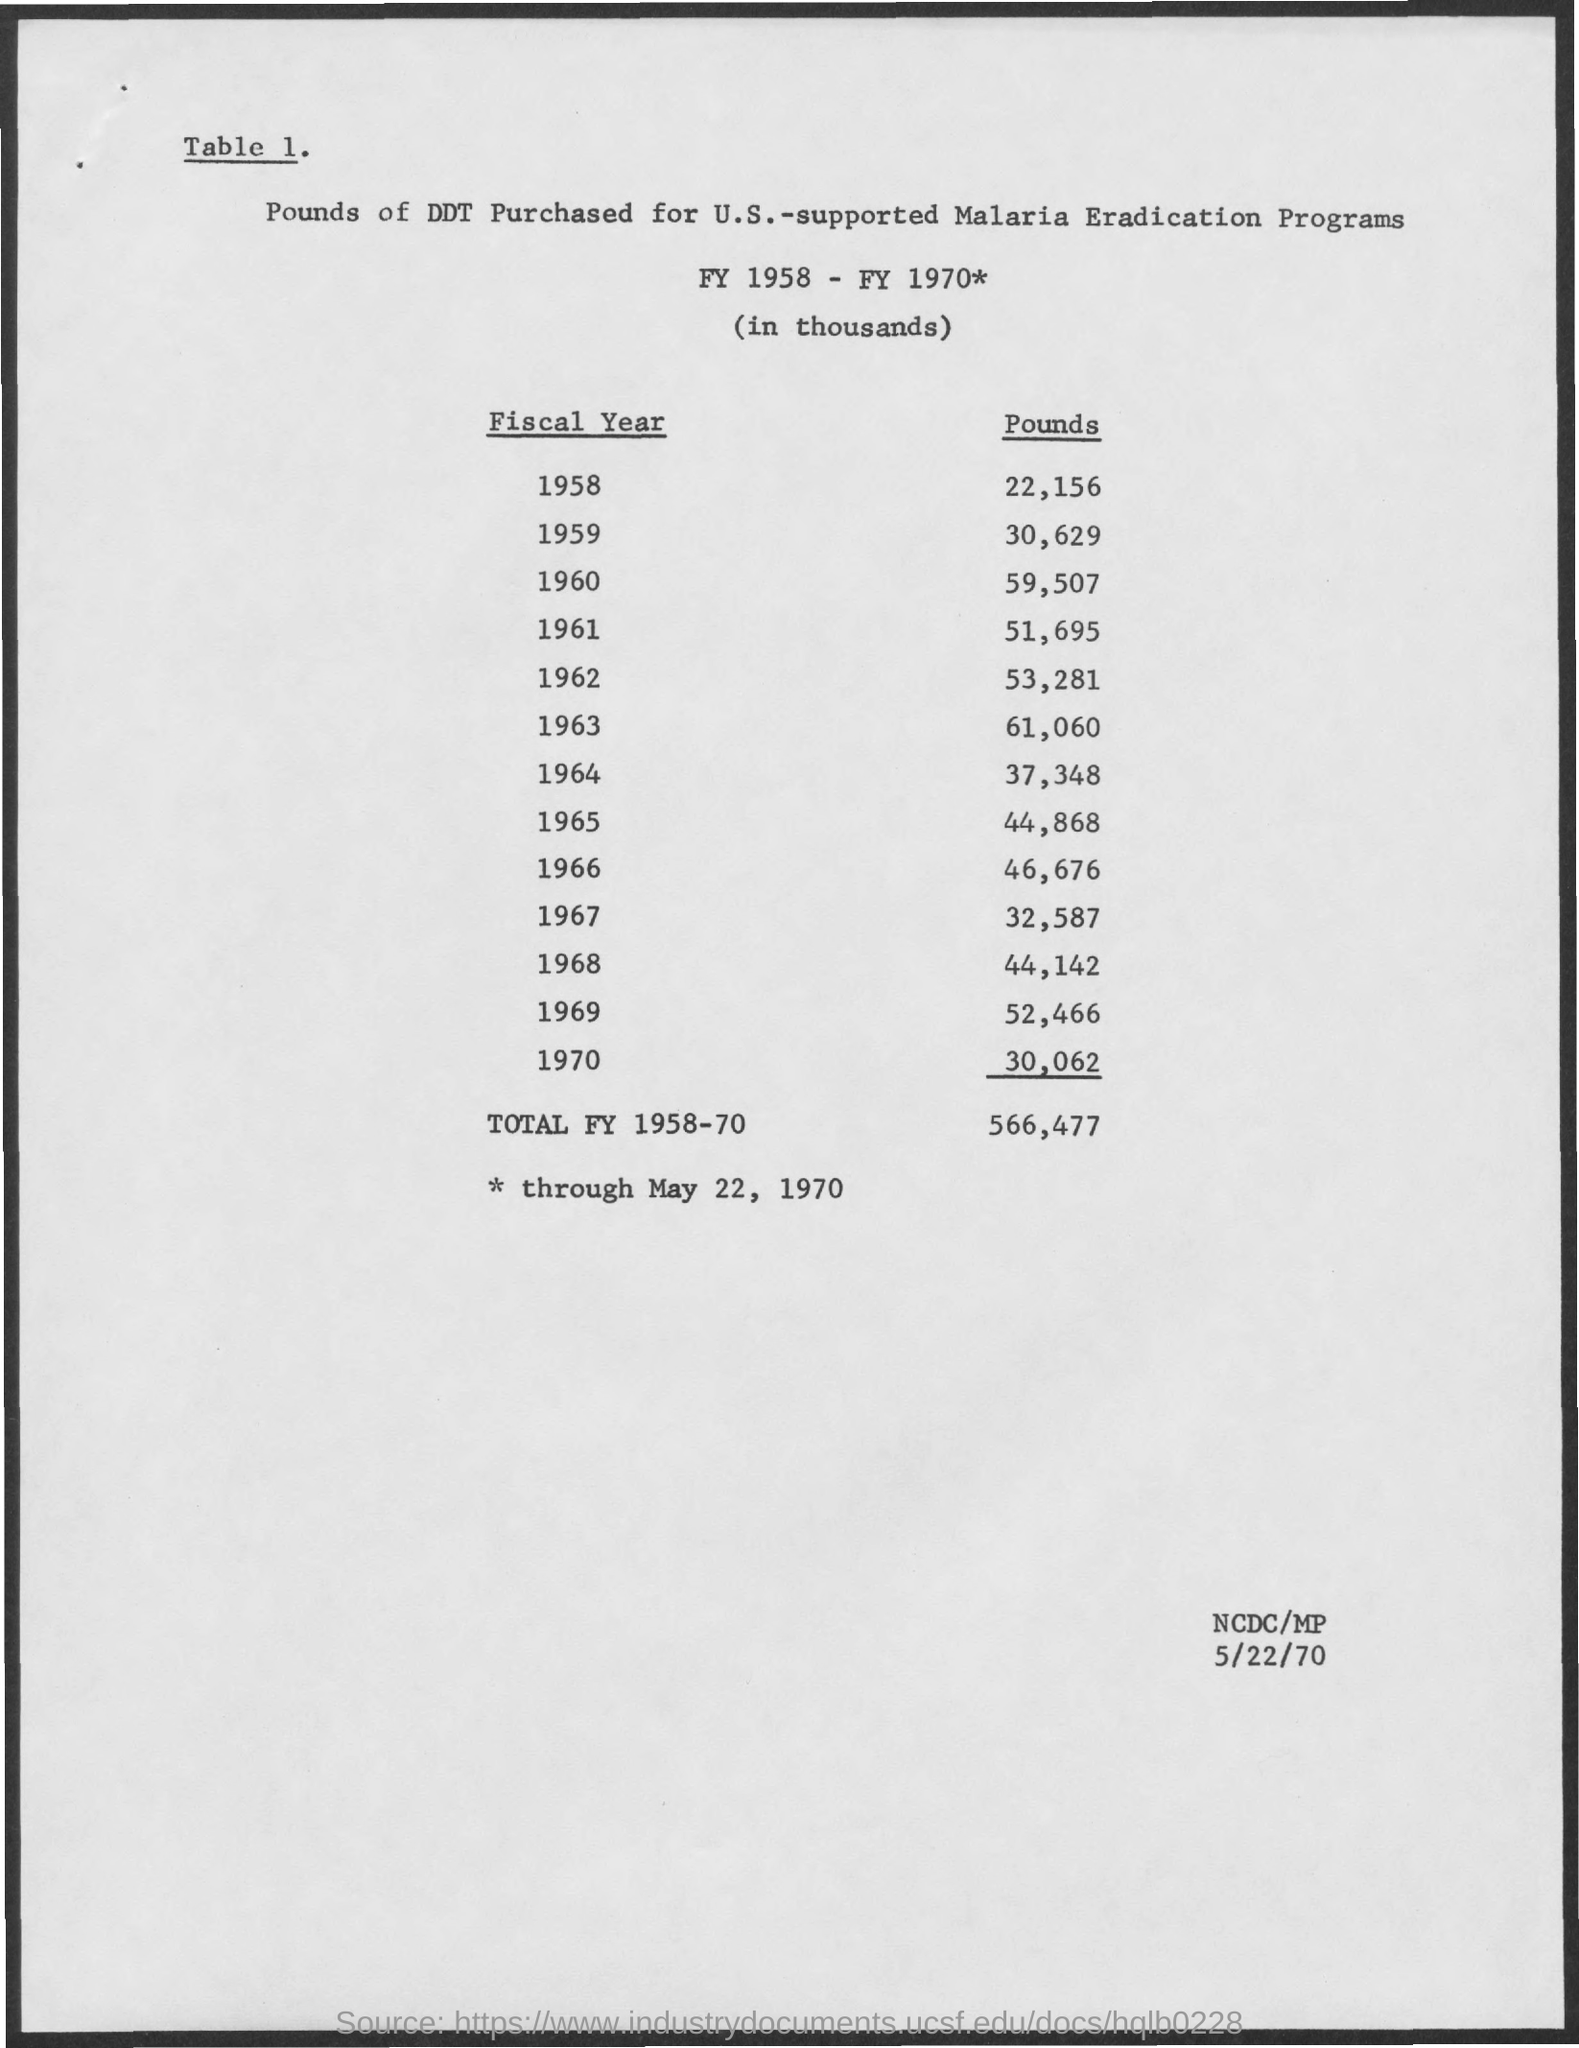What was purchased in pounds for U.S.?
Make the answer very short. Ddt. How much ddt was purchased in the fiscal year 1958?
Your answer should be compact. 22,156. How much ddt was purchased in total for fy 1958-70?
Keep it short and to the point. 566,477. What is the date mentioned in bottom right corner?
Your response must be concise. 5/22/70. 